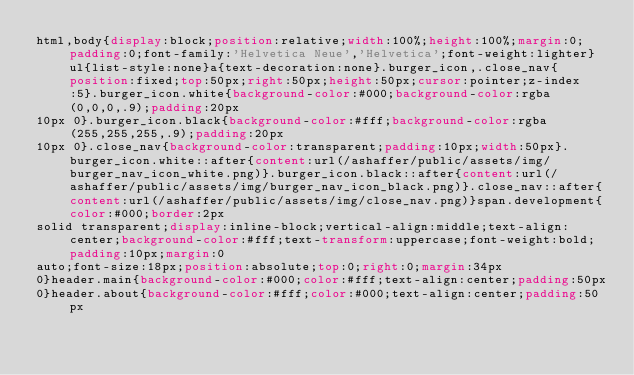Convert code to text. <code><loc_0><loc_0><loc_500><loc_500><_CSS_>html,body{display:block;position:relative;width:100%;height:100%;margin:0;padding:0;font-family:'Helvetica Neue','Helvetica';font-weight:lighter}ul{list-style:none}a{text-decoration:none}.burger_icon,.close_nav{position:fixed;top:50px;right:50px;height:50px;cursor:pointer;z-index:5}.burger_icon.white{background-color:#000;background-color:rgba(0,0,0,.9);padding:20px
10px 0}.burger_icon.black{background-color:#fff;background-color:rgba(255,255,255,.9);padding:20px
10px 0}.close_nav{background-color:transparent;padding:10px;width:50px}.burger_icon.white::after{content:url(/ashaffer/public/assets/img/burger_nav_icon_white.png)}.burger_icon.black::after{content:url(/ashaffer/public/assets/img/burger_nav_icon_black.png)}.close_nav::after{content:url(/ashaffer/public/assets/img/close_nav.png)}span.development{color:#000;border:2px
solid transparent;display:inline-block;vertical-align:middle;text-align:center;background-color:#fff;text-transform:uppercase;font-weight:bold;padding:10px;margin:0
auto;font-size:18px;position:absolute;top:0;right:0;margin:34px
0}header.main{background-color:#000;color:#fff;text-align:center;padding:50px
0}header.about{background-color:#fff;color:#000;text-align:center;padding:50px</code> 